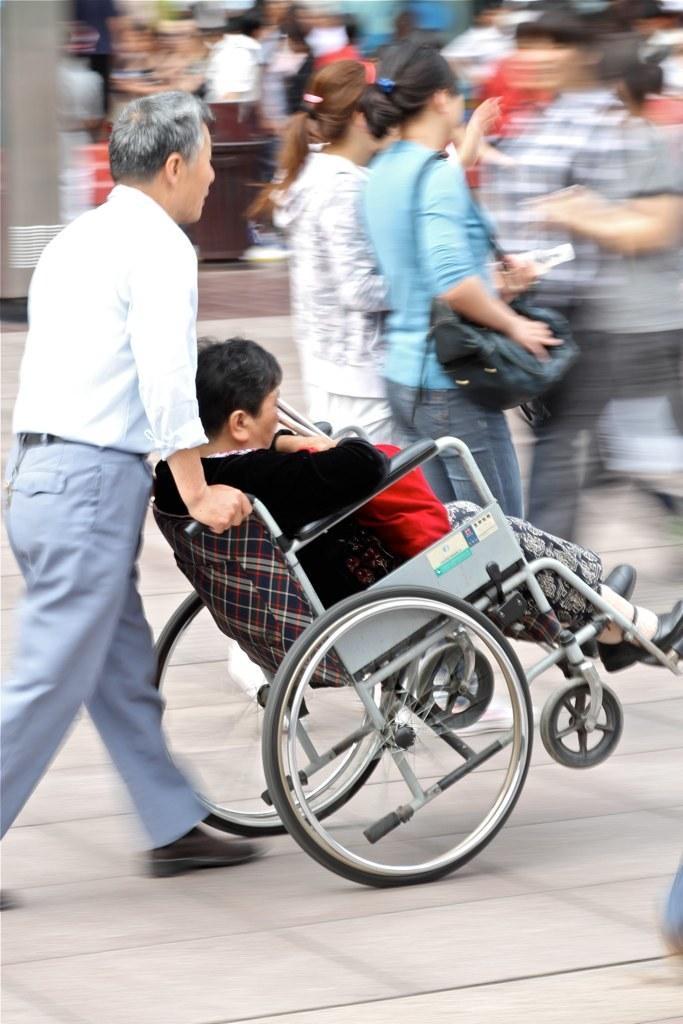Could you give a brief overview of what you see in this image? In this picture we can observe a person sitting in the wheel chair. There is another person who is pushing the wheelchair. He is wearing white shirt. There are some people standing. We can observe men and women in this picture. The background is completely blurred. 